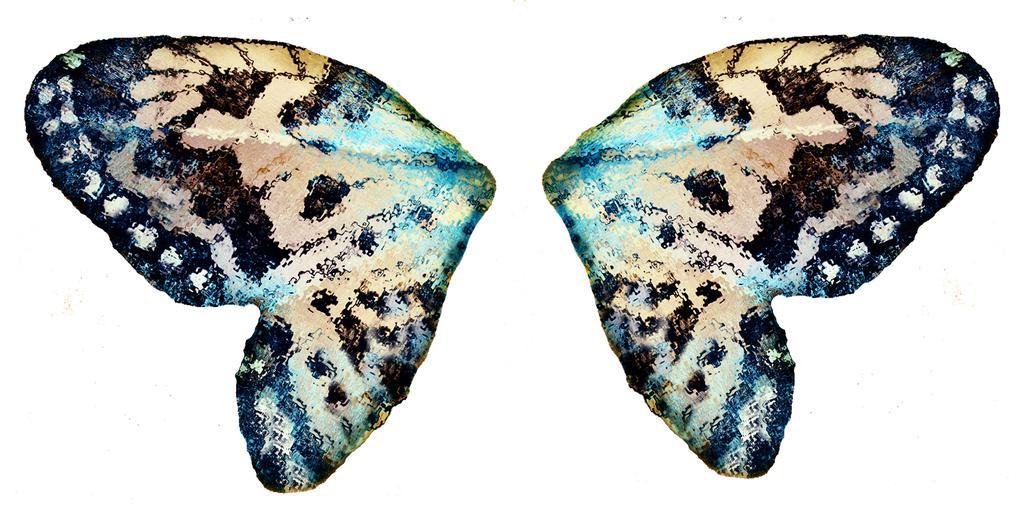Please provide a concise description of this image. In this image I can see two butterfly wings. The background is white in color. This image is taken may be during a day. 